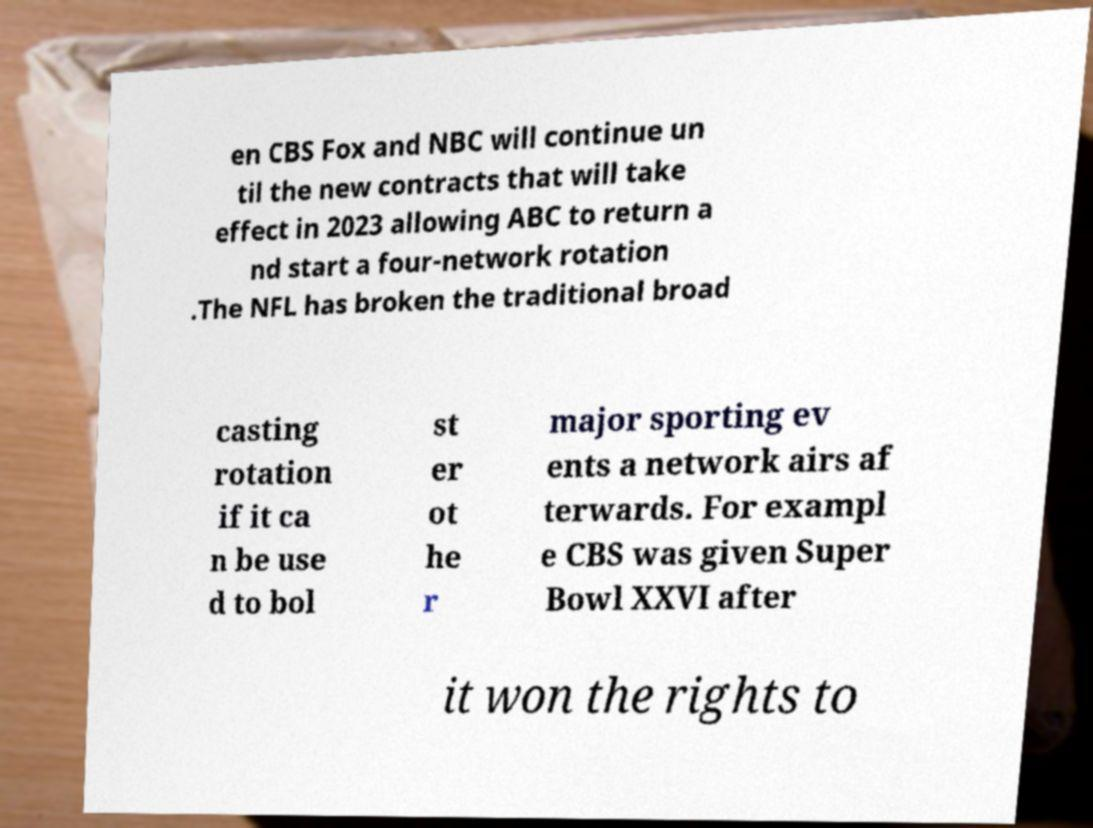There's text embedded in this image that I need extracted. Can you transcribe it verbatim? en CBS Fox and NBC will continue un til the new contracts that will take effect in 2023 allowing ABC to return a nd start a four-network rotation .The NFL has broken the traditional broad casting rotation if it ca n be use d to bol st er ot he r major sporting ev ents a network airs af terwards. For exampl e CBS was given Super Bowl XXVI after it won the rights to 